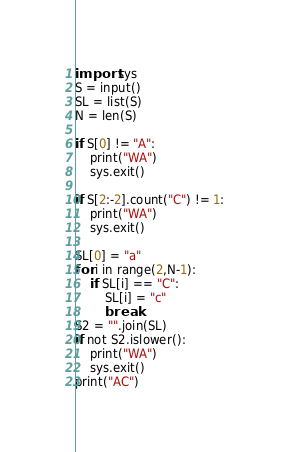Convert code to text. <code><loc_0><loc_0><loc_500><loc_500><_Python_>import sys
S = input()
SL = list(S)
N = len(S)

if S[0] != "A":
    print("WA")
    sys.exit()

if S[2:-2].count("C") != 1:
    print("WA")
    sys.exit()

SL[0] = "a"
for i in range(2,N-1):
    if SL[i] == "C":
        SL[i] = "c"
        break
S2 = "".join(SL)
if not S2.islower():
    print("WA")
    sys.exit()
print("AC")
</code> 